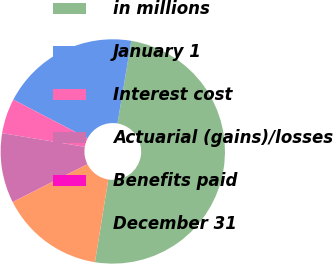<chart> <loc_0><loc_0><loc_500><loc_500><pie_chart><fcel>in millions<fcel>January 1<fcel>Interest cost<fcel>Actuarial (gains)/losses<fcel>Benefits paid<fcel>December 31<nl><fcel>49.91%<fcel>19.99%<fcel>5.03%<fcel>10.02%<fcel>0.04%<fcel>15.0%<nl></chart> 